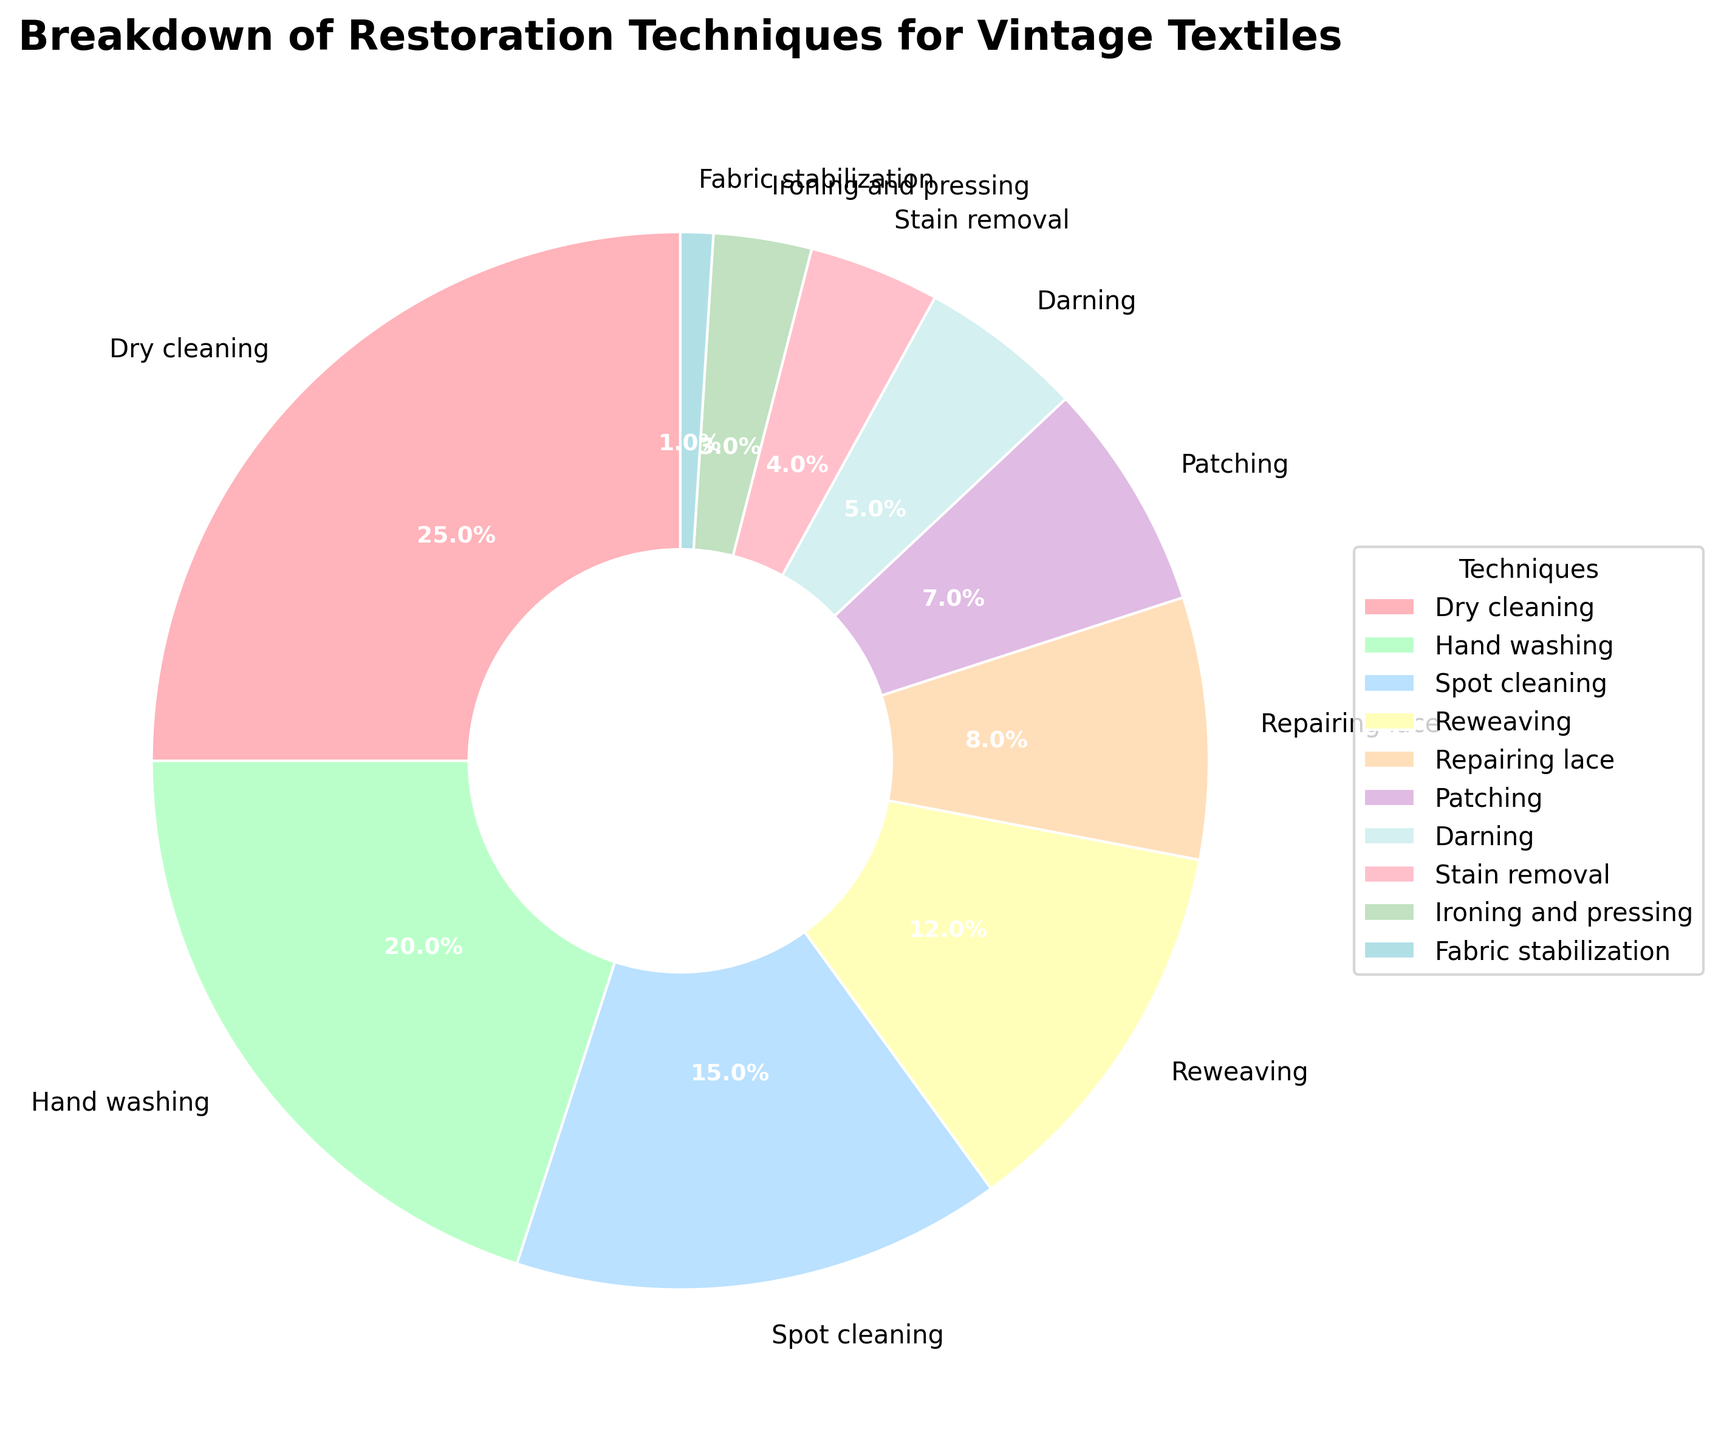What is the most common restoration technique used for vintage textiles? By looking at the pie chart, the slice with the largest percentage represents the most common technique. The largest slice is for Dry Cleaning, labeled with 25%.
Answer: Dry Cleaning Which restoration techniques together constitute 35% of the total? By looking at the pie chart, we can sum the slices starting from the largest until we reach 35% or more. Dry Cleaning is 25% and Hand Washing is 20%. Together these constitute 45%, which exceeds 35%. However, only Dry Cleaning and Spot Cleaning together make 25% + 15% = 40%, so the combination Dry Cleaning and Spot Cleaning can reach exactly 35%.
Answer: Dry Cleaning, Spot Cleaning Which restoration technique is represented by a green slice? Visual identification can help here; looking for the green-colored slice, which is labeled as representing "Hand Washing" in the legend.
Answer: Hand Washing How much larger is the percentage for Dry Cleaning compared to Darning? By looking at the pieces of the pie chart, Dry Cleaning is 25% and Darning is 5%. The difference between them is calculated as 25% - 5%.
Answer: 20% Is the percentage for Spot Cleaning larger or smaller than the percentage for Patching and Reweaving combined? Spot Cleaning is 15%. Patching is 7% and Reweaving is 12%. Adding Patching and Reweaving gives 7% + 12% = 19%.  As 15% is smaller than 19%, the percentage for Spot Cleaning is smaller than for Patching and Reweaving combined.
Answer: Smaller Which two techniques combined make up the smallest percentage in the chart and what is their combined percentage? By identifying the two smallest slices, Fabric Stabilization (1%) and Ironing and Pressing (3%), their combined percentage is 1% + 3%.
Answer: Fabric Stabilization and Ironing and Pressing, 4% What is the combined percentage for Hand Washing, Reweaving, and Repairing Lace? Adding the percentages from the pie chart: Hand Washing (20%), Reweaving (12%), and Repairing Lace (8%). The sum total is 20% + 12% + 8%.
Answer: 40% How does the percentage for Hand Washing compare to that of Spot Cleaning, in percentage points? Hand Washing is 20% and Spot Cleaning is 15%; comparing these two values, the difference is calculated as 20% - 15%.
Answer: 5% What is the total percentage of techniques that involve "cleaning"? Techniques involving "cleaning" include Dry Cleaning (25%), Hand Washing (20%), Spot Cleaning (15%), and Stain Removal (4%). Adding them together: 25% + 20% + 15% + 4%.
Answer: 64% Which color is used to represent Patching in the pie chart? By visually identifying the color of the slice labeled as Patching, the pie chart shows Patching in what looks like a peach or light orange color.
Answer: Light Orange 